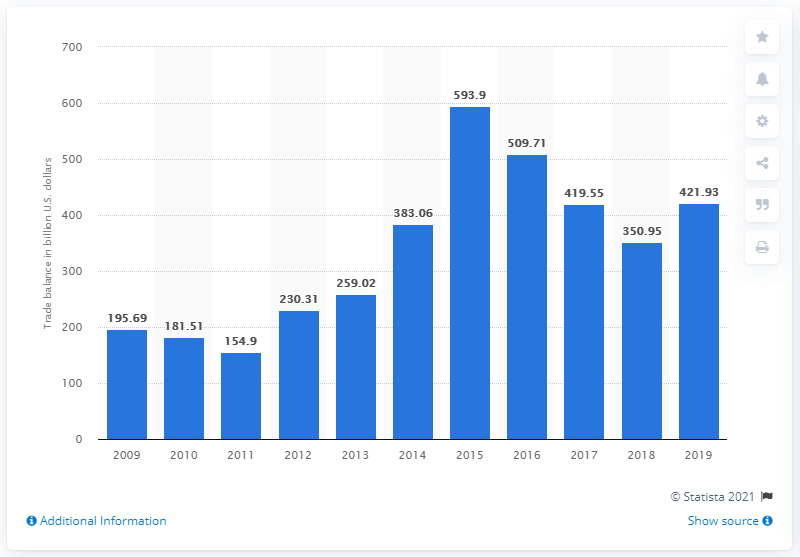List a handful of essential elements in this visual. In 2015, China's merchandise trade surplus was 593.9 billion U.S. dollars. In 2019, China's merchandise trade surplus was 421.93. 